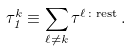<formula> <loc_0><loc_0><loc_500><loc_500>\tau _ { 1 } ^ { k } \equiv \sum _ { \ell \neq k } \tau ^ { \ell \colon \text {rest} } \, .</formula> 